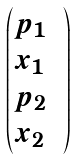<formula> <loc_0><loc_0><loc_500><loc_500>\begin{pmatrix} p _ { 1 } & \\ x _ { 1 } & \\ p _ { 2 } \\ x _ { 2 } \end{pmatrix}</formula> 